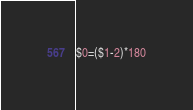<code> <loc_0><loc_0><loc_500><loc_500><_Awk_>$0=($1-2)*180</code> 